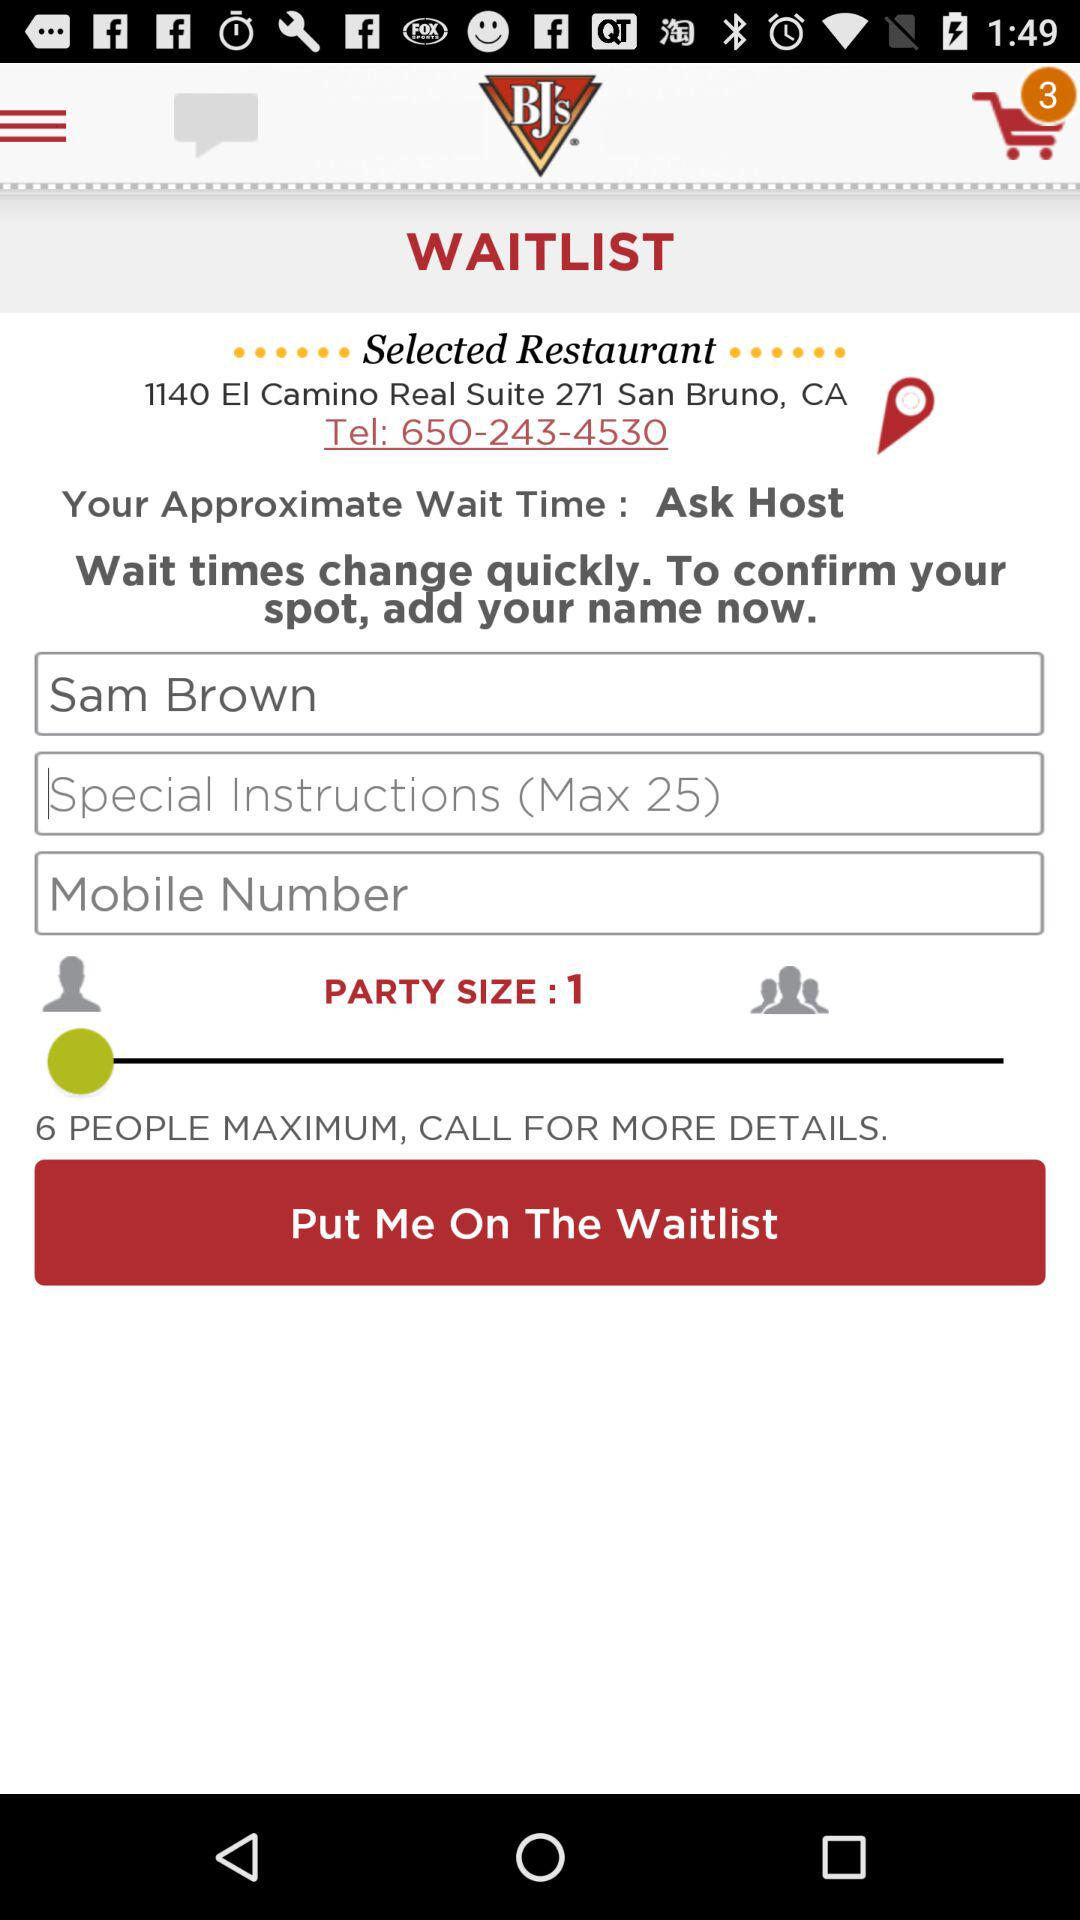How many maximum number of people are allowed in the party? The maximum number of people allowed in the party is 6. 